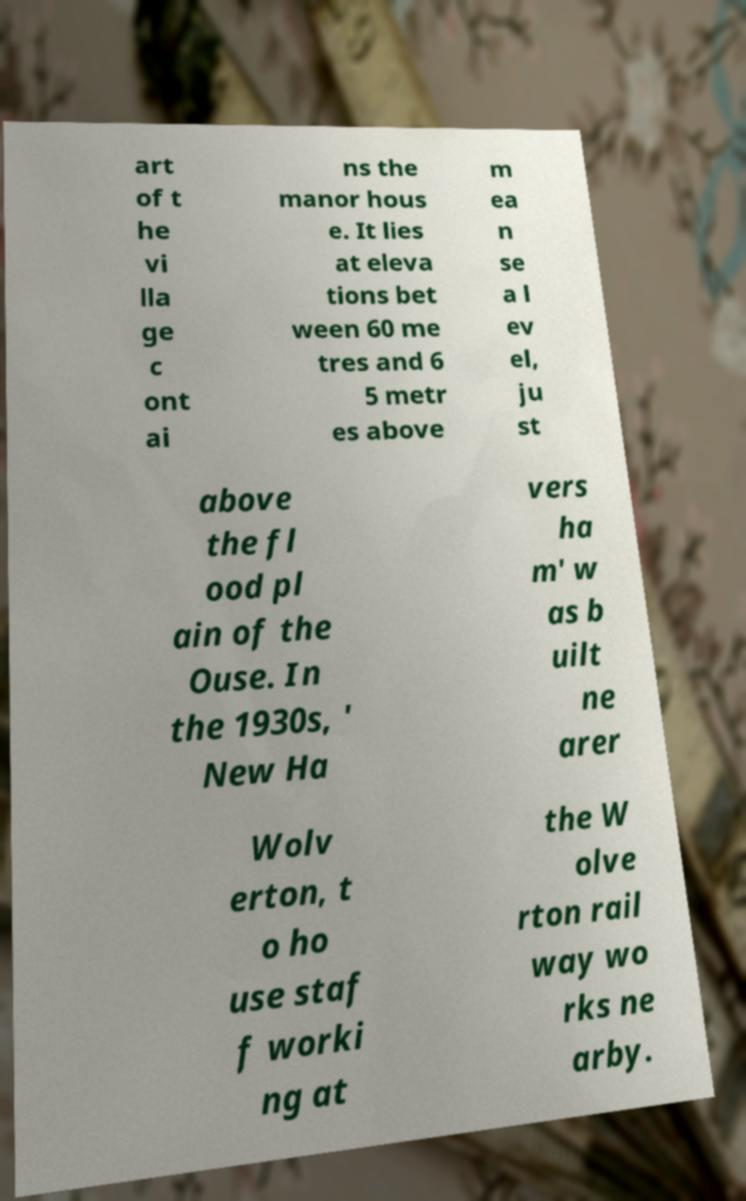There's text embedded in this image that I need extracted. Can you transcribe it verbatim? art of t he vi lla ge c ont ai ns the manor hous e. It lies at eleva tions bet ween 60 me tres and 6 5 metr es above m ea n se a l ev el, ju st above the fl ood pl ain of the Ouse. In the 1930s, ' New Ha vers ha m' w as b uilt ne arer Wolv erton, t o ho use staf f worki ng at the W olve rton rail way wo rks ne arby. 